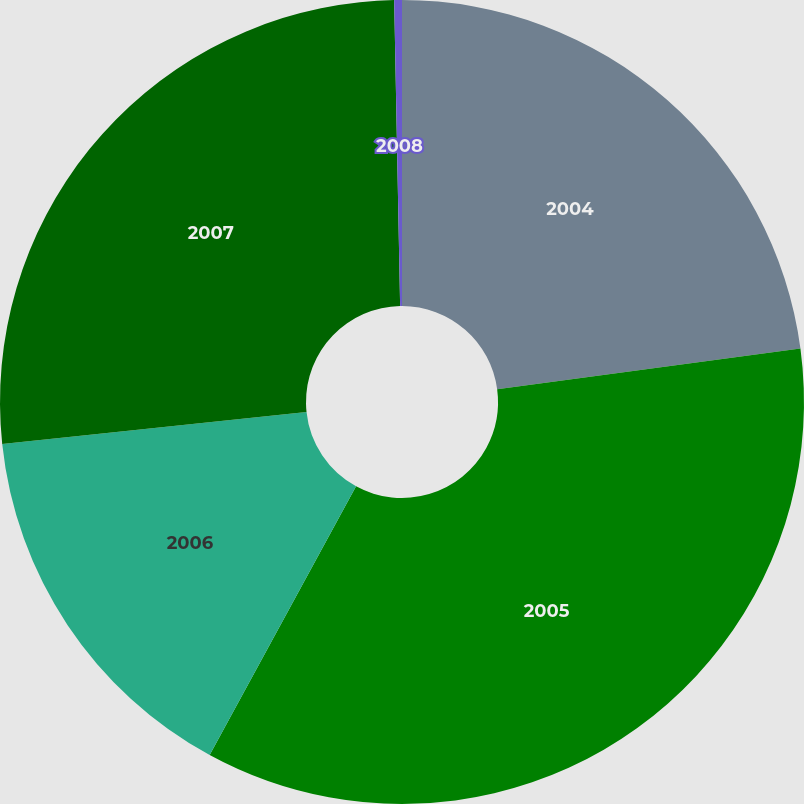Convert chart. <chart><loc_0><loc_0><loc_500><loc_500><pie_chart><fcel>2004<fcel>2005<fcel>2006<fcel>2007<fcel>2008<nl><fcel>22.88%<fcel>35.06%<fcel>15.39%<fcel>26.36%<fcel>0.31%<nl></chart> 